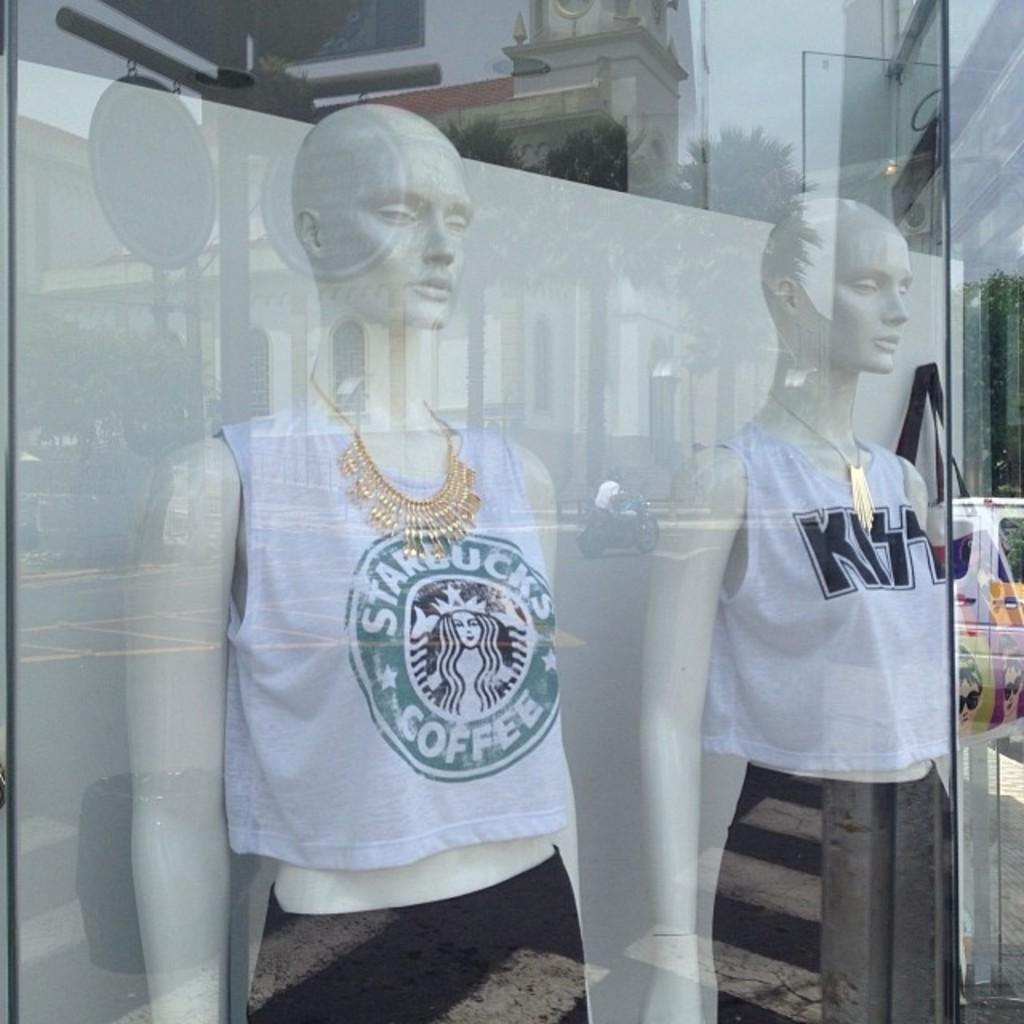Provide a one-sentence caption for the provided image. Two mannequins on display wearing Starbucks and Kiss shirts. 